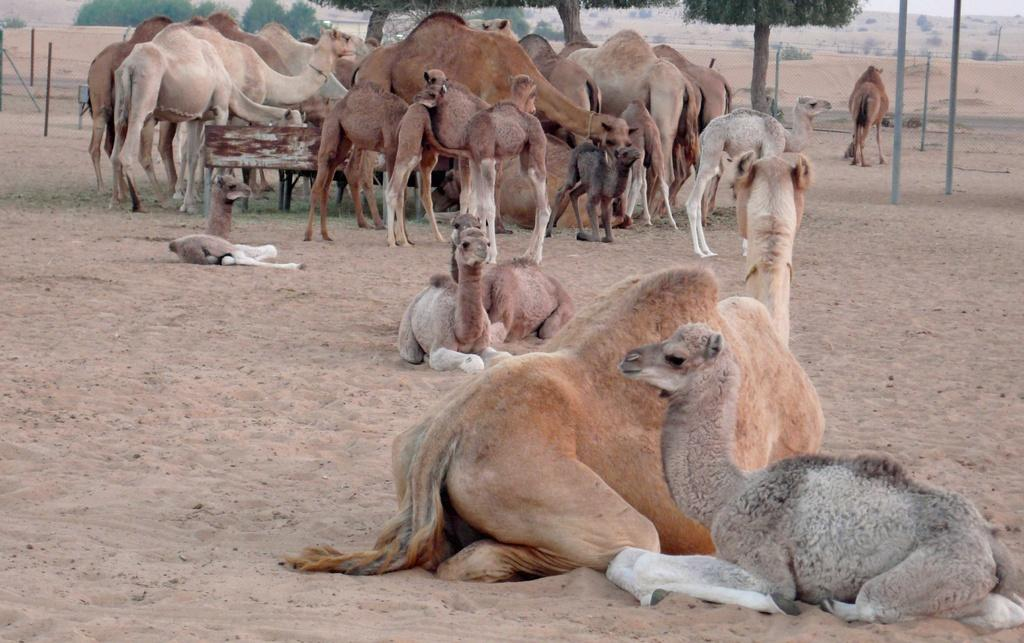What type of animals can be seen in the image? There are many camels in the image. What is the ground made of in the image? There is sand at the bottom of the image. What can be seen in the background of the image? There are trees and poles in the background of the image. What type of seating is present in the middle of the image? There is a wooden bench in the middle of the image. What color is the orange that is being peeled in the image? There is no orange present in the image; it features camels, sand, trees, poles, and a wooden bench. What type of game is being played on the wooden bench in the image? There is no game being played in the image; the wooden bench is simply a piece of seating. 